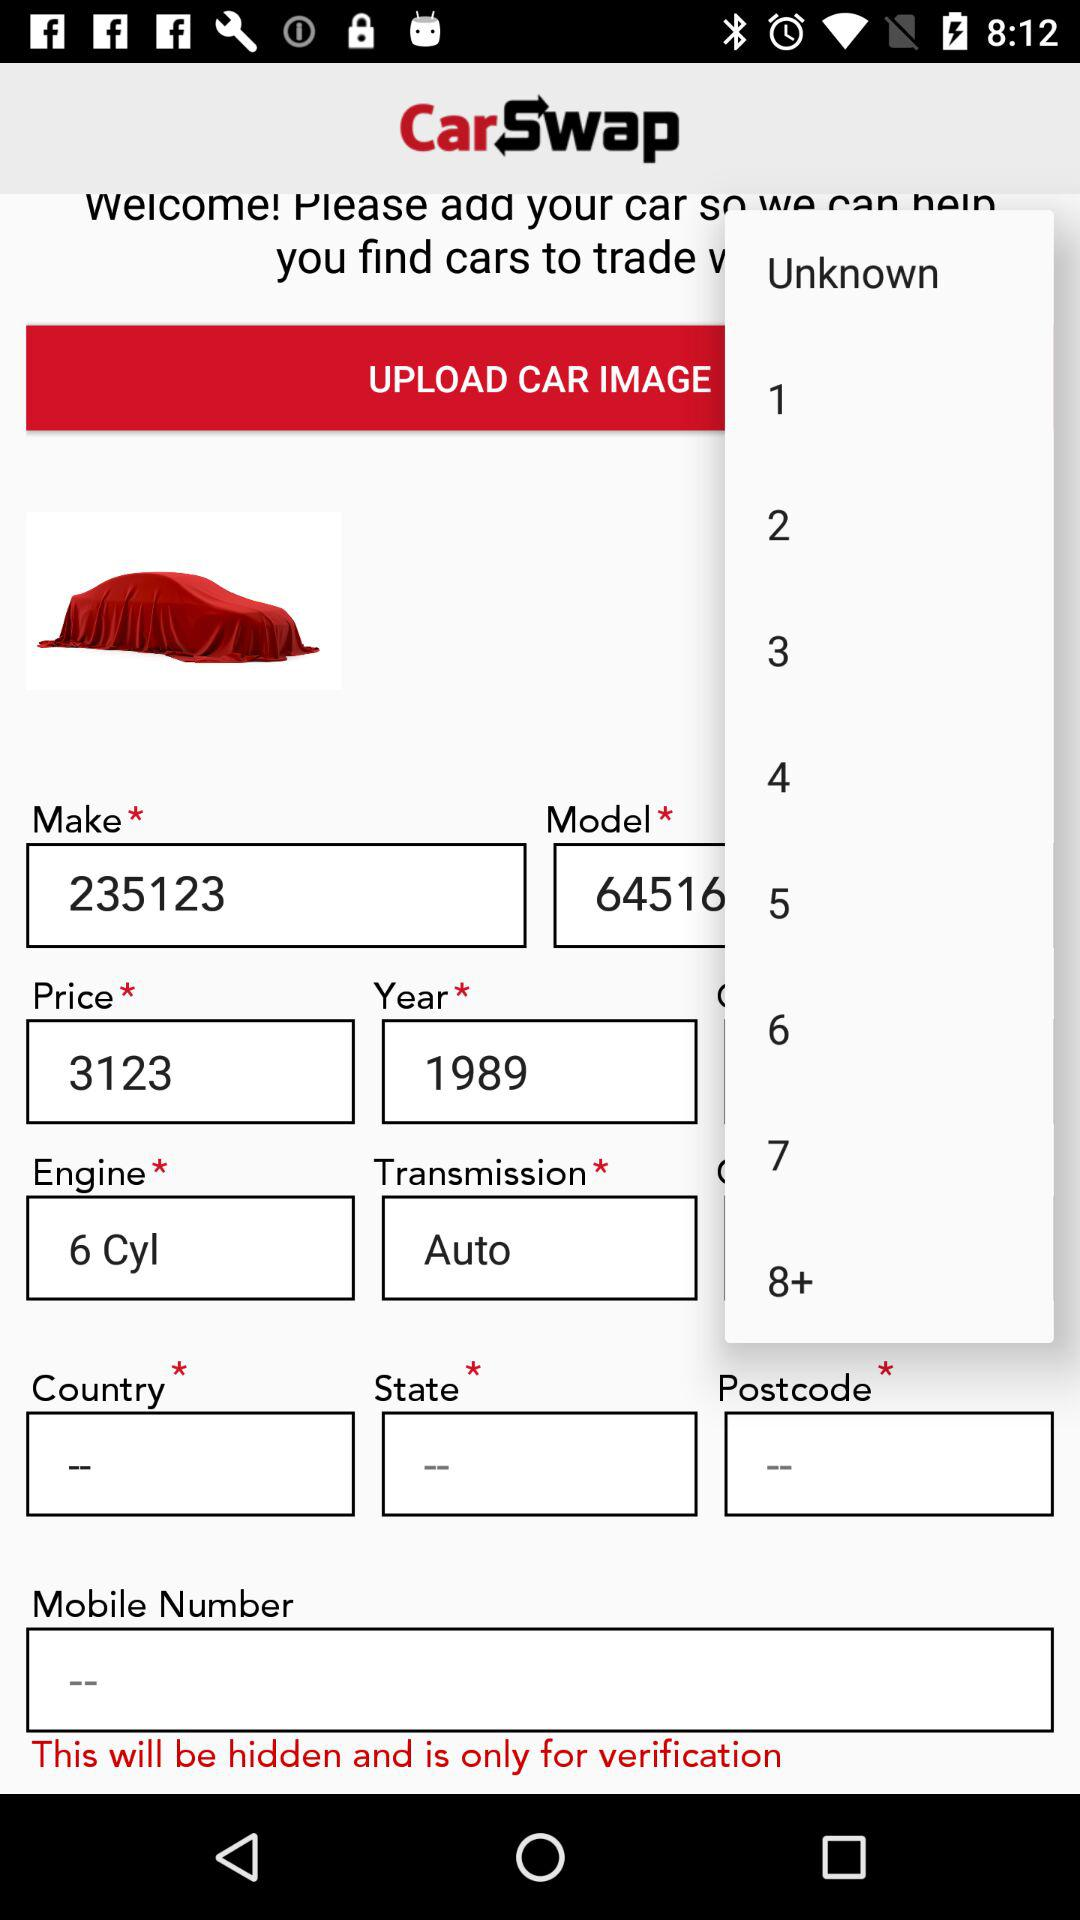Which year is mentioned? The mentioned year is 1989. 